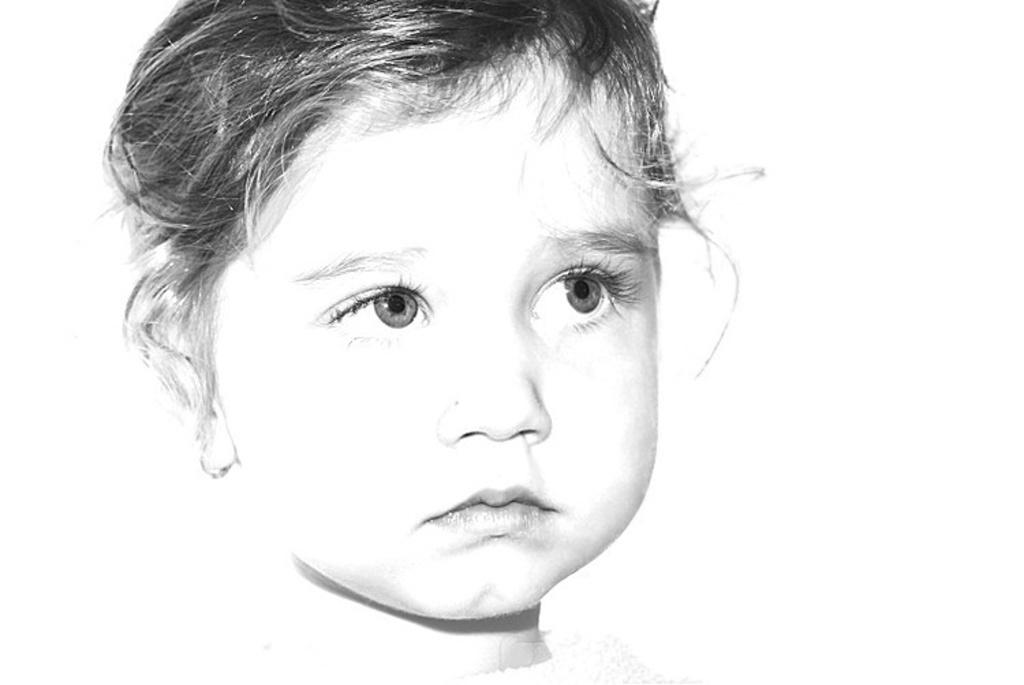Who is the main subject in the picture? There is a girl in the picture. What color is the background of the image? The background of the image is white. How many birds are perched on the girl's chin in the image? There are no birds present in the image, and therefore no birds can be seen on the girl's chin. 